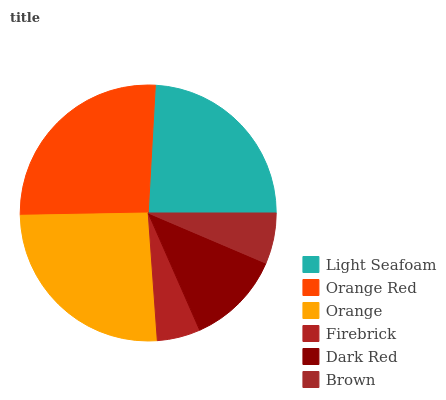Is Firebrick the minimum?
Answer yes or no. Yes. Is Orange Red the maximum?
Answer yes or no. Yes. Is Orange the minimum?
Answer yes or no. No. Is Orange the maximum?
Answer yes or no. No. Is Orange Red greater than Orange?
Answer yes or no. Yes. Is Orange less than Orange Red?
Answer yes or no. Yes. Is Orange greater than Orange Red?
Answer yes or no. No. Is Orange Red less than Orange?
Answer yes or no. No. Is Light Seafoam the high median?
Answer yes or no. Yes. Is Dark Red the low median?
Answer yes or no. Yes. Is Brown the high median?
Answer yes or no. No. Is Orange the low median?
Answer yes or no. No. 